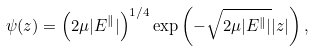Convert formula to latex. <formula><loc_0><loc_0><loc_500><loc_500>\psi ( z ) = \left ( 2 \mu | E ^ { \| } | \right ) ^ { 1 / 4 } \exp \left ( - \sqrt { 2 \mu | E ^ { \| } | } | z | \right ) ,</formula> 